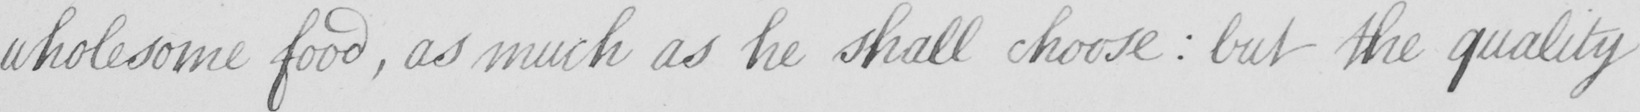Can you tell me what this handwritten text says? wholesome food , as much as he shall choose  :  but the quality 